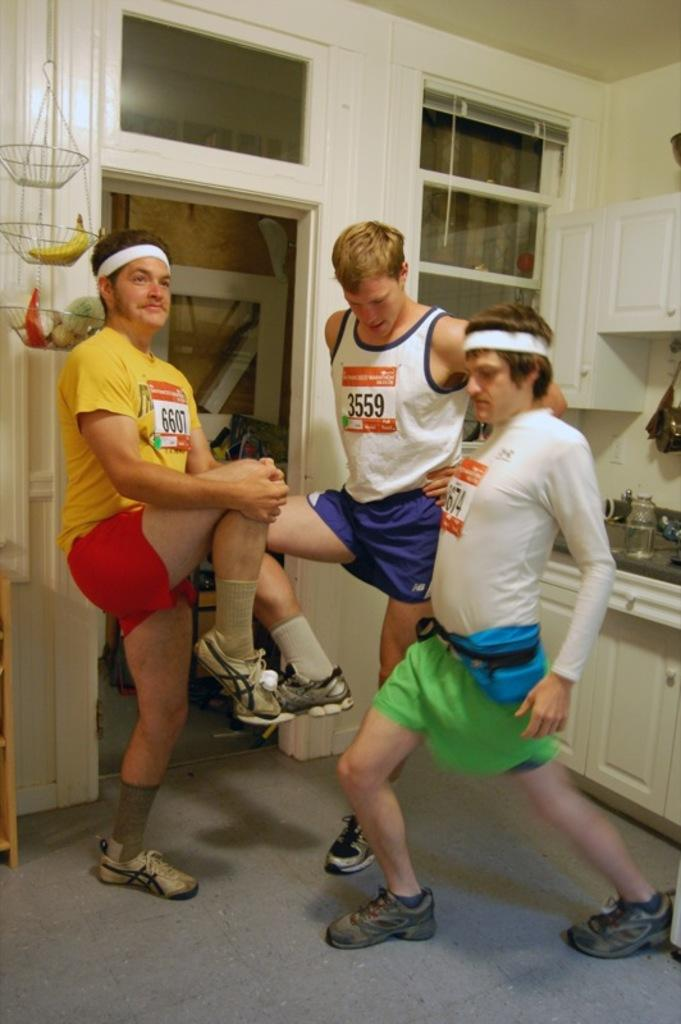Who or what can be seen in the image? There are people in the image. What architectural features are visible in the background? There is a door and windows in the background of the image. What type of tree is being destroyed by the organization in the image? There is no tree, organization, or destruction present in the image. 